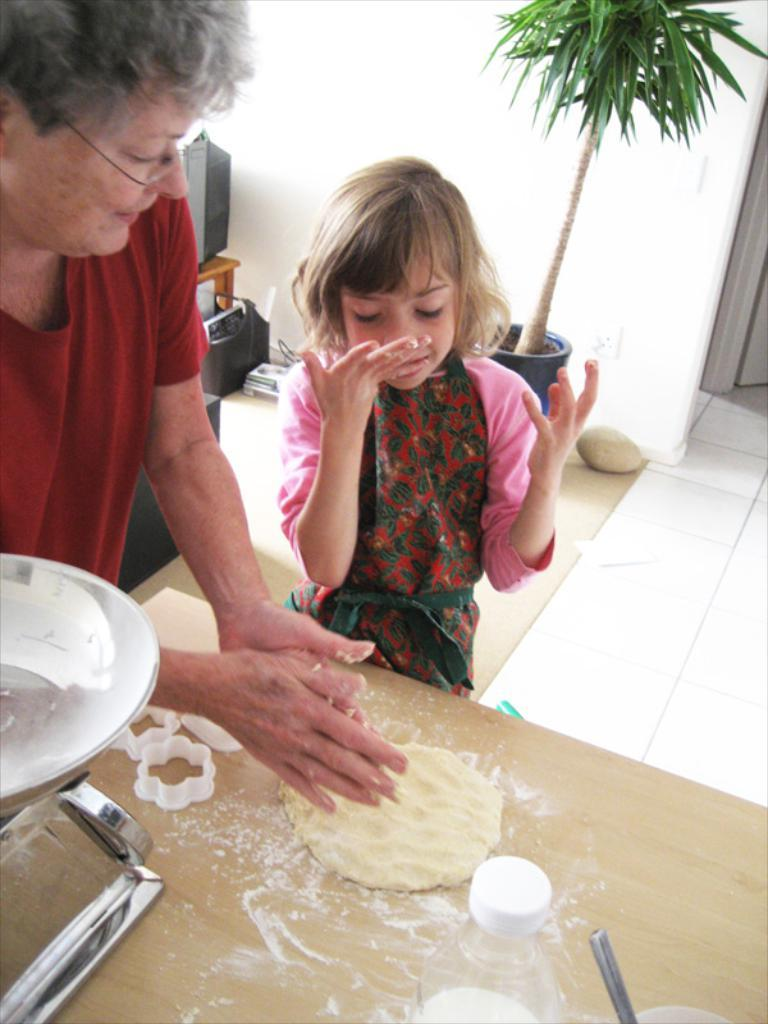What is present in the image besides the people? There is a plant in the image. How are the two people positioned in relation to the plant? The two people are standing in front of the plant. What is the purpose of the table in the image? There is a table in the image, but its purpose is not specified. What can be found on the table? There are things on the table, but their nature is not described. How many cherries are on the brain of the deer in the image? There is no deer or brain present in the image; it features a plant and two people standing in front of it. 